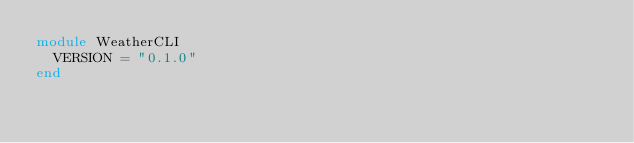Convert code to text. <code><loc_0><loc_0><loc_500><loc_500><_Ruby_>module WeatherCLI
  VERSION = "0.1.0"
end
</code> 